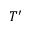Convert formula to latex. <formula><loc_0><loc_0><loc_500><loc_500>T ^ { \prime }</formula> 